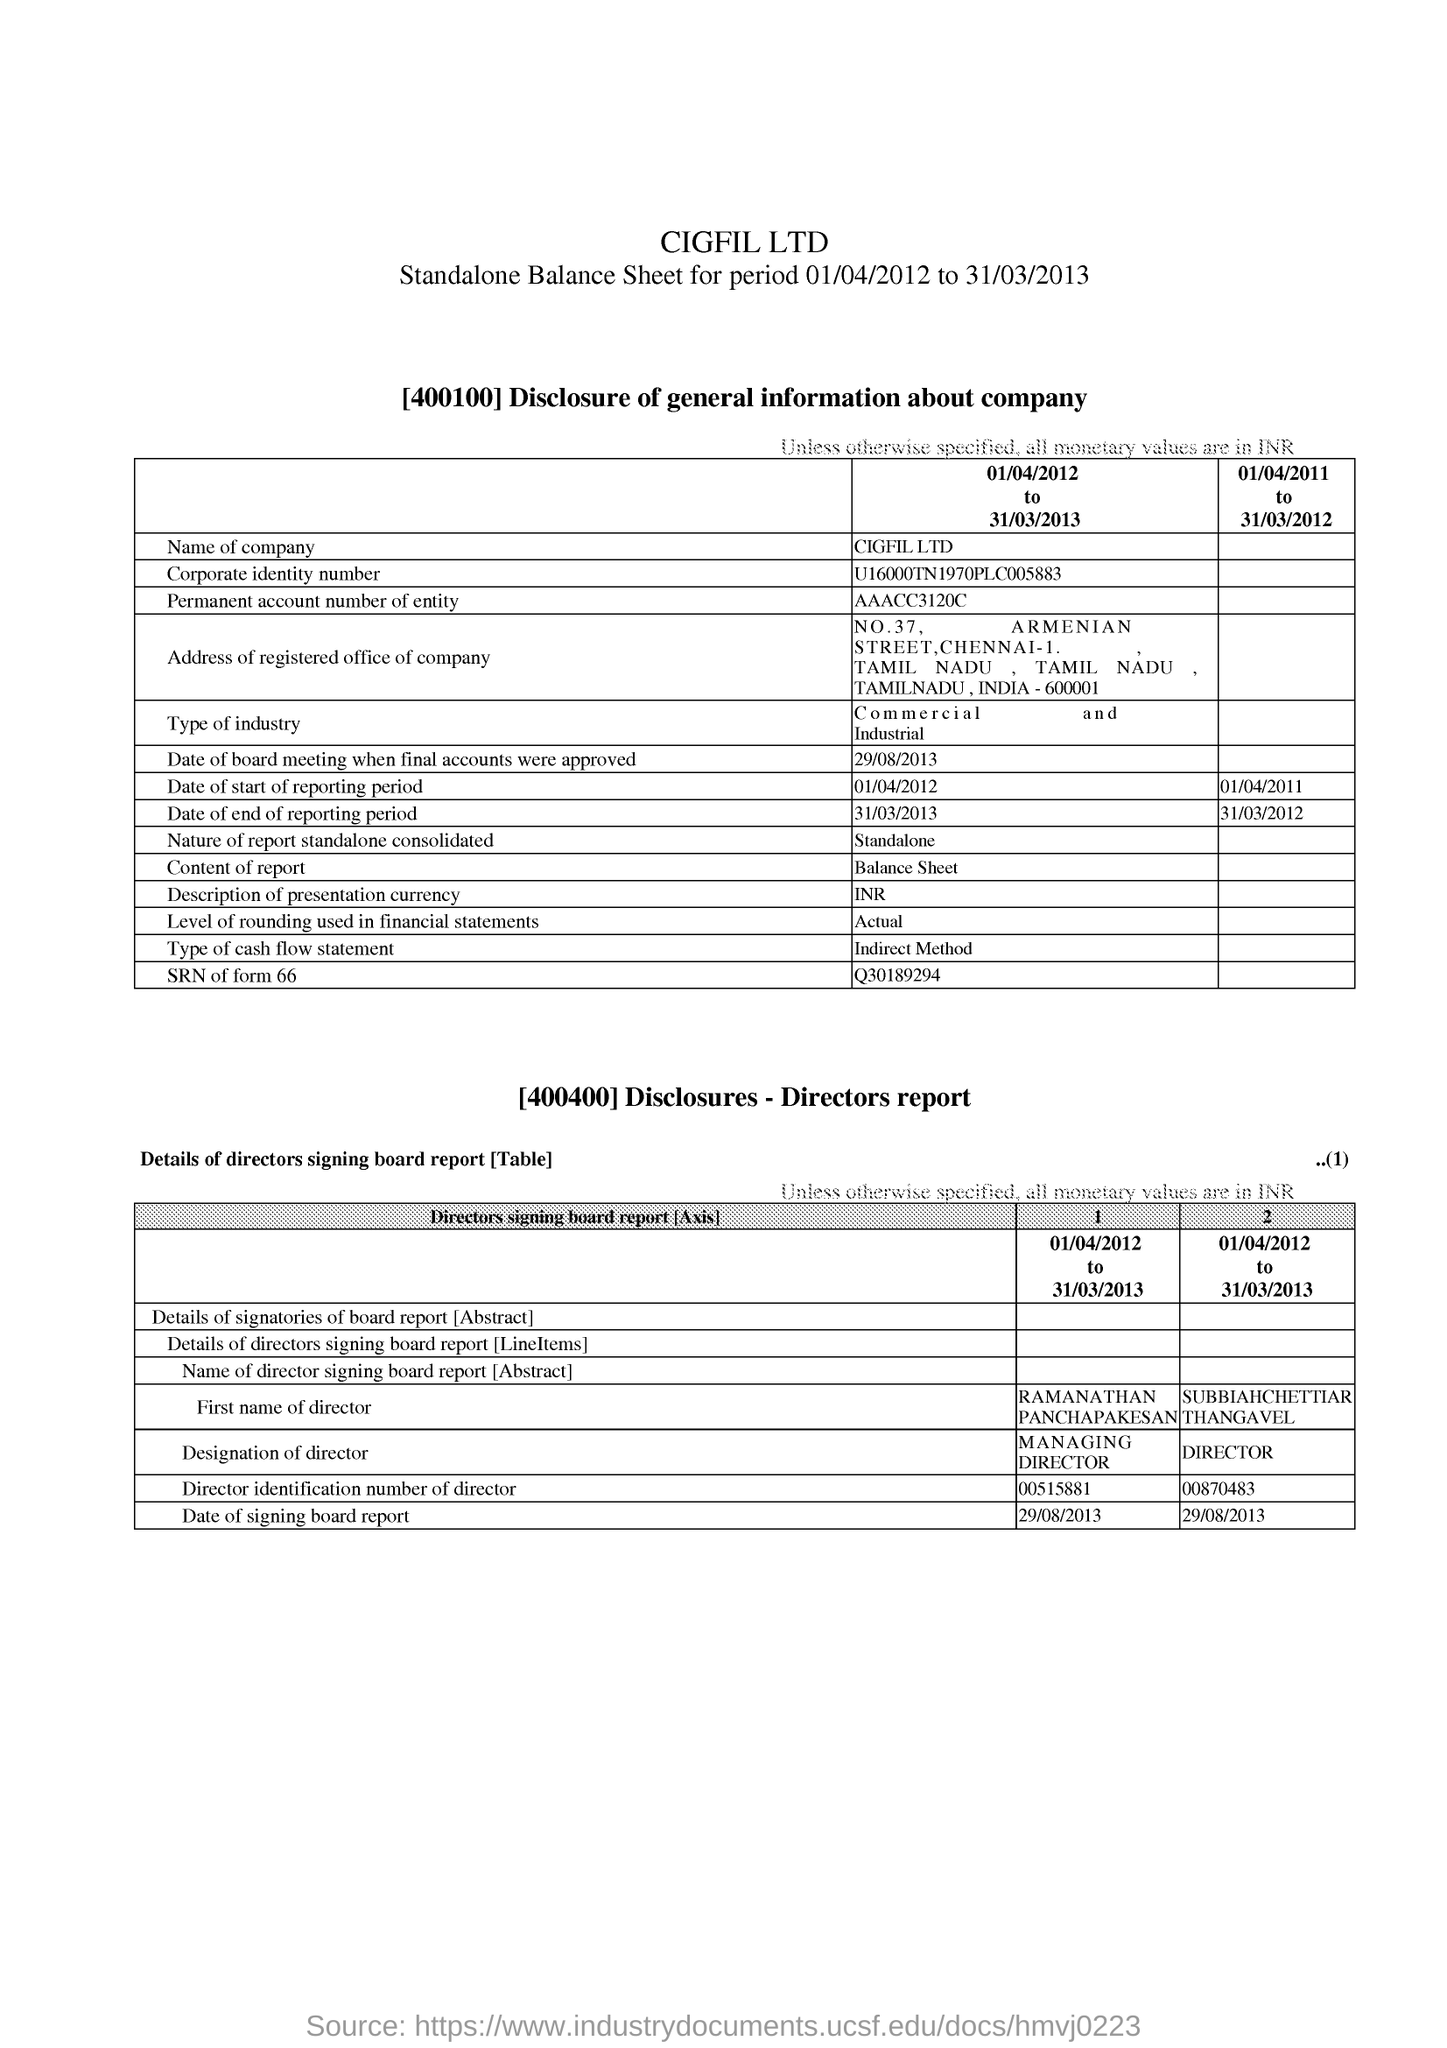What is a permanent account number of the entity?
Offer a terse response. AAACC3120C. What is a type of cash flow statement?
Give a very brief answer. Indirect Method. What is the date of signing board report?
Ensure brevity in your answer.  29/08/2013. What is the name of the company?
Your answer should be compact. CIGFIL LTD. 